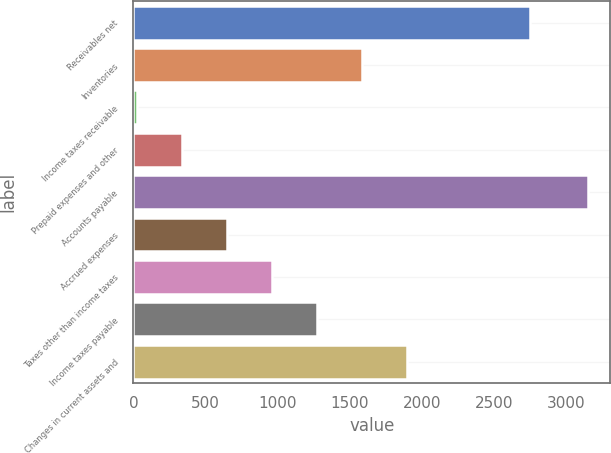Convert chart. <chart><loc_0><loc_0><loc_500><loc_500><bar_chart><fcel>Receivables net<fcel>Inventories<fcel>Income taxes receivable<fcel>Prepaid expenses and other<fcel>Accounts payable<fcel>Accrued expenses<fcel>Taxes other than income taxes<fcel>Income taxes payable<fcel>Changes in current assets and<nl><fcel>2753<fcel>1586<fcel>23<fcel>335.6<fcel>3149<fcel>648.2<fcel>960.8<fcel>1273.4<fcel>1898.6<nl></chart> 